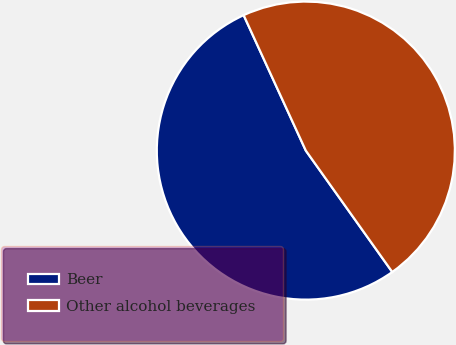Convert chart to OTSL. <chart><loc_0><loc_0><loc_500><loc_500><pie_chart><fcel>Beer<fcel>Other alcohol beverages<nl><fcel>53.0%<fcel>47.0%<nl></chart> 